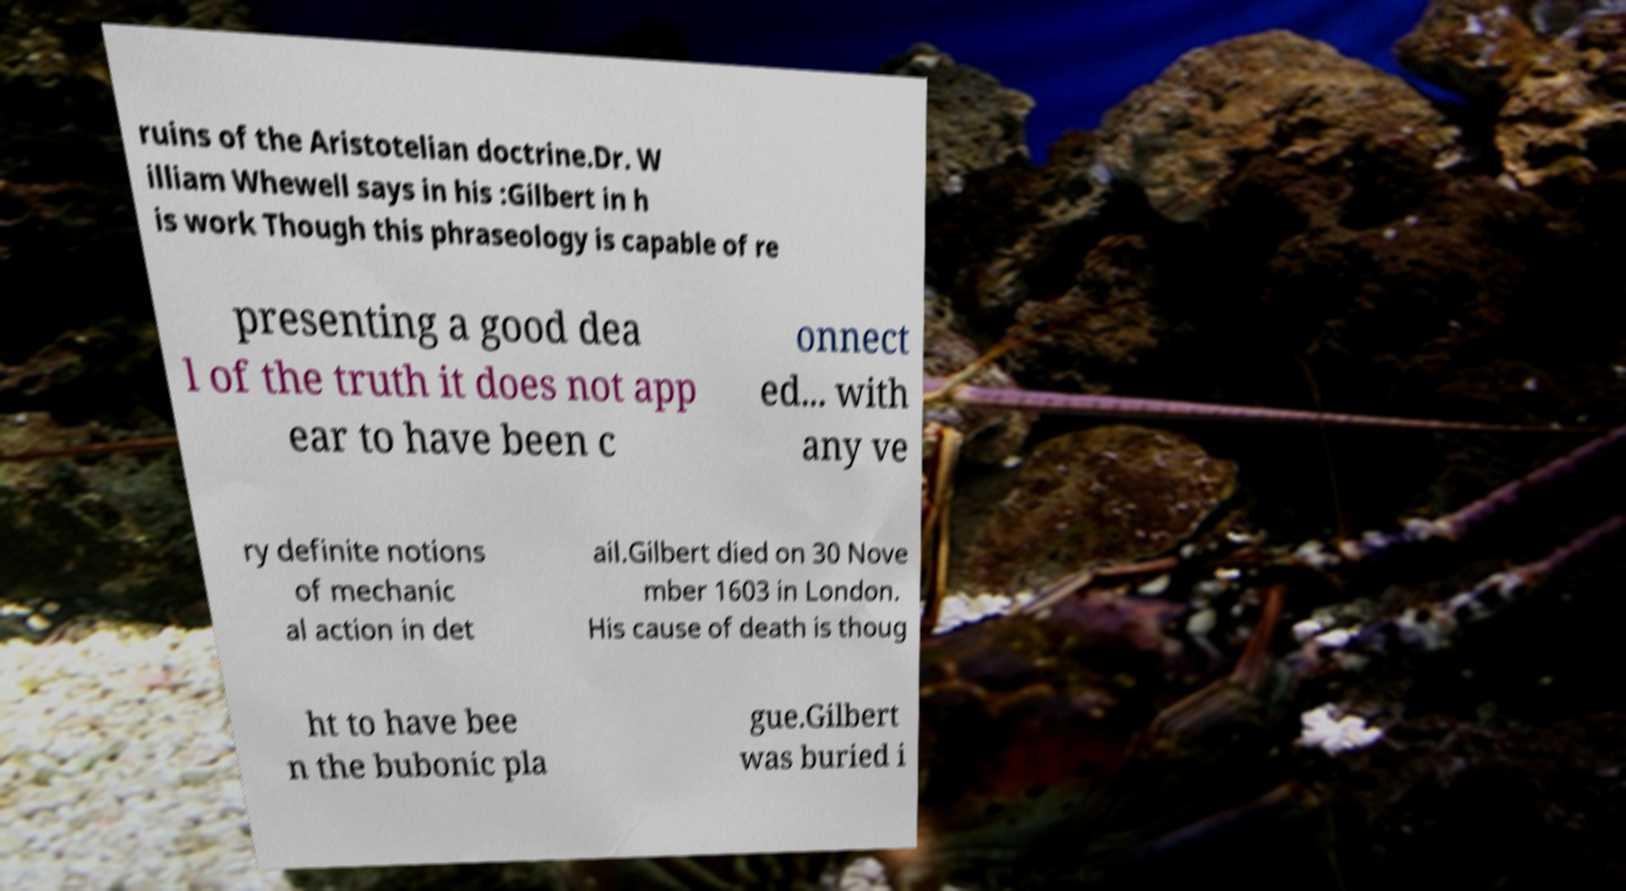I need the written content from this picture converted into text. Can you do that? ruins of the Aristotelian doctrine.Dr. W illiam Whewell says in his :Gilbert in h is work Though this phraseology is capable of re presenting a good dea l of the truth it does not app ear to have been c onnect ed... with any ve ry definite notions of mechanic al action in det ail.Gilbert died on 30 Nove mber 1603 in London. His cause of death is thoug ht to have bee n the bubonic pla gue.Gilbert was buried i 